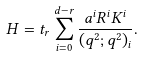Convert formula to latex. <formula><loc_0><loc_0><loc_500><loc_500>H = t _ { r } \sum _ { i = 0 } ^ { d - r } \frac { a ^ { i } R ^ { i } K ^ { i } } { ( q ^ { 2 } ; q ^ { 2 } ) _ { i } } .</formula> 